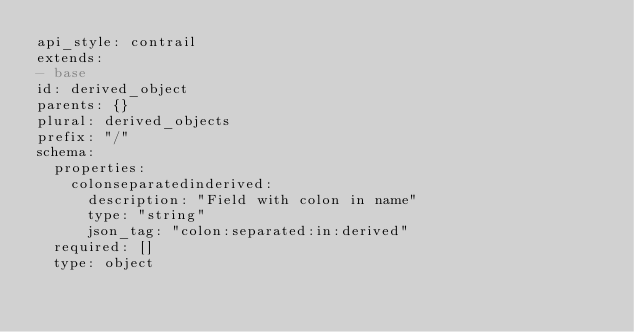Convert code to text. <code><loc_0><loc_0><loc_500><loc_500><_YAML_>api_style: contrail
extends:
- base
id: derived_object
parents: {}
plural: derived_objects
prefix: "/"
schema:
  properties:
    colonseparatedinderived:
      description: "Field with colon in name"
      type: "string"
      json_tag: "colon:separated:in:derived"
  required: []
  type: object

</code> 